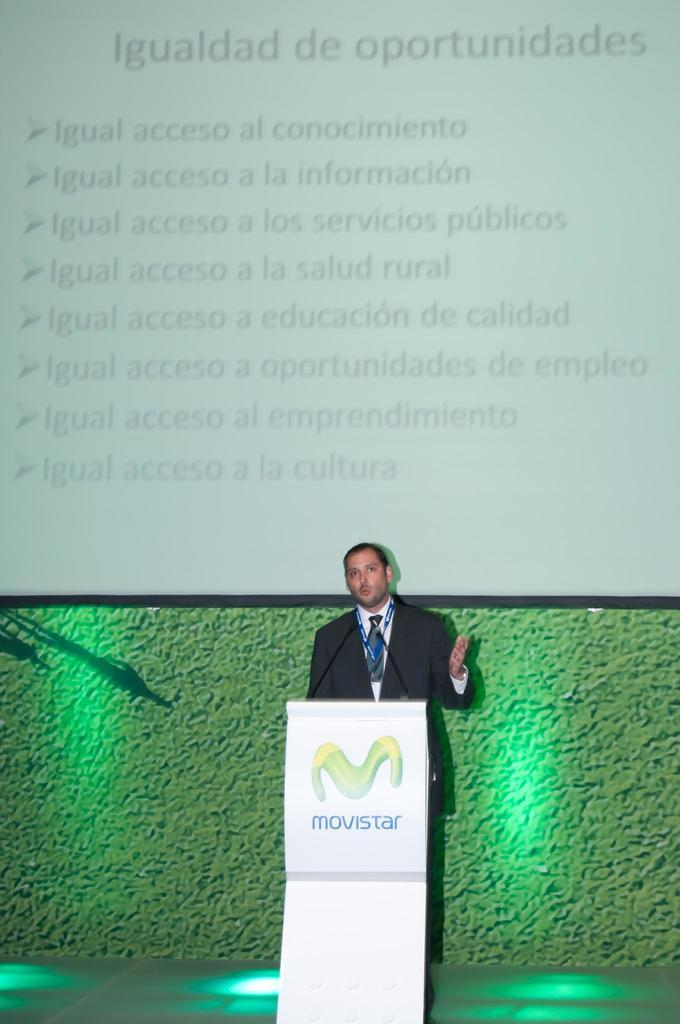Who is the person in the image? There is a man in the image. What is the man wearing? The man is wearing a black suit. Where is the man standing in the image? The man is standing in front of a dias. What is the man doing in the image? The man is talking on a microphone. What can be seen on the wall behind the man? There is a screen on the wall behind the man. What type of coal is being used to fuel the man's speech in the image? There is no coal present in the image, and the man's speech is not fueled by coal. 